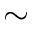<formula> <loc_0><loc_0><loc_500><loc_500>\sim</formula> 